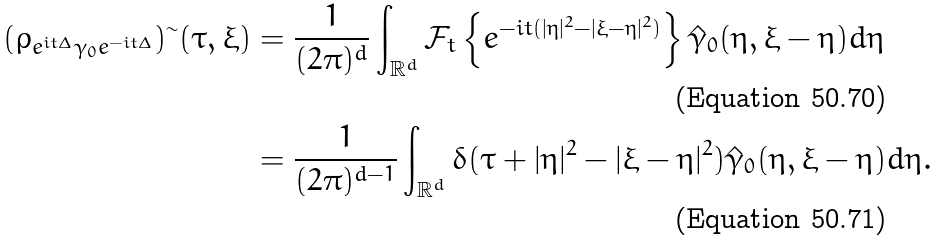Convert formula to latex. <formula><loc_0><loc_0><loc_500><loc_500>( \rho _ { e ^ { i t \Delta } \gamma _ { 0 } e ^ { - i t \Delta } } ) ^ { \sim } ( \tau , \xi ) & = \frac { 1 } { ( 2 \pi ) ^ { d } } \int _ { \mathbb { R } ^ { d } } \mathcal { F } _ { t } \left \{ e ^ { - i t ( | \eta | ^ { 2 } - | \xi - \eta | ^ { 2 } ) } \right \} \hat { \gamma } _ { 0 } ( \eta , \xi - \eta ) d \eta \\ & = \frac { 1 } { ( 2 \pi ) ^ { d - 1 } } \int _ { \mathbb { R } ^ { d } } \delta ( \tau + | \eta | ^ { 2 } - | \xi - \eta | ^ { 2 } ) \hat { \gamma } _ { 0 } ( \eta , \xi - \eta ) d \eta .</formula> 